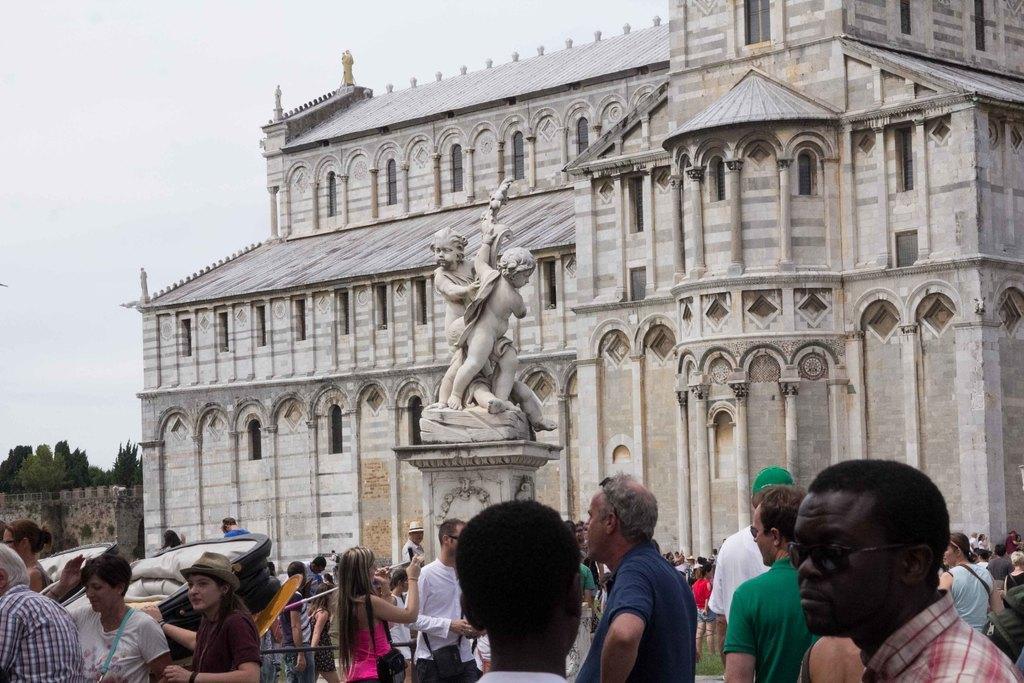Describe this image in one or two sentences. In this picture I can see people are standing on the ground. In the background I can see statue and building. On the left side I can see trees and sky. 